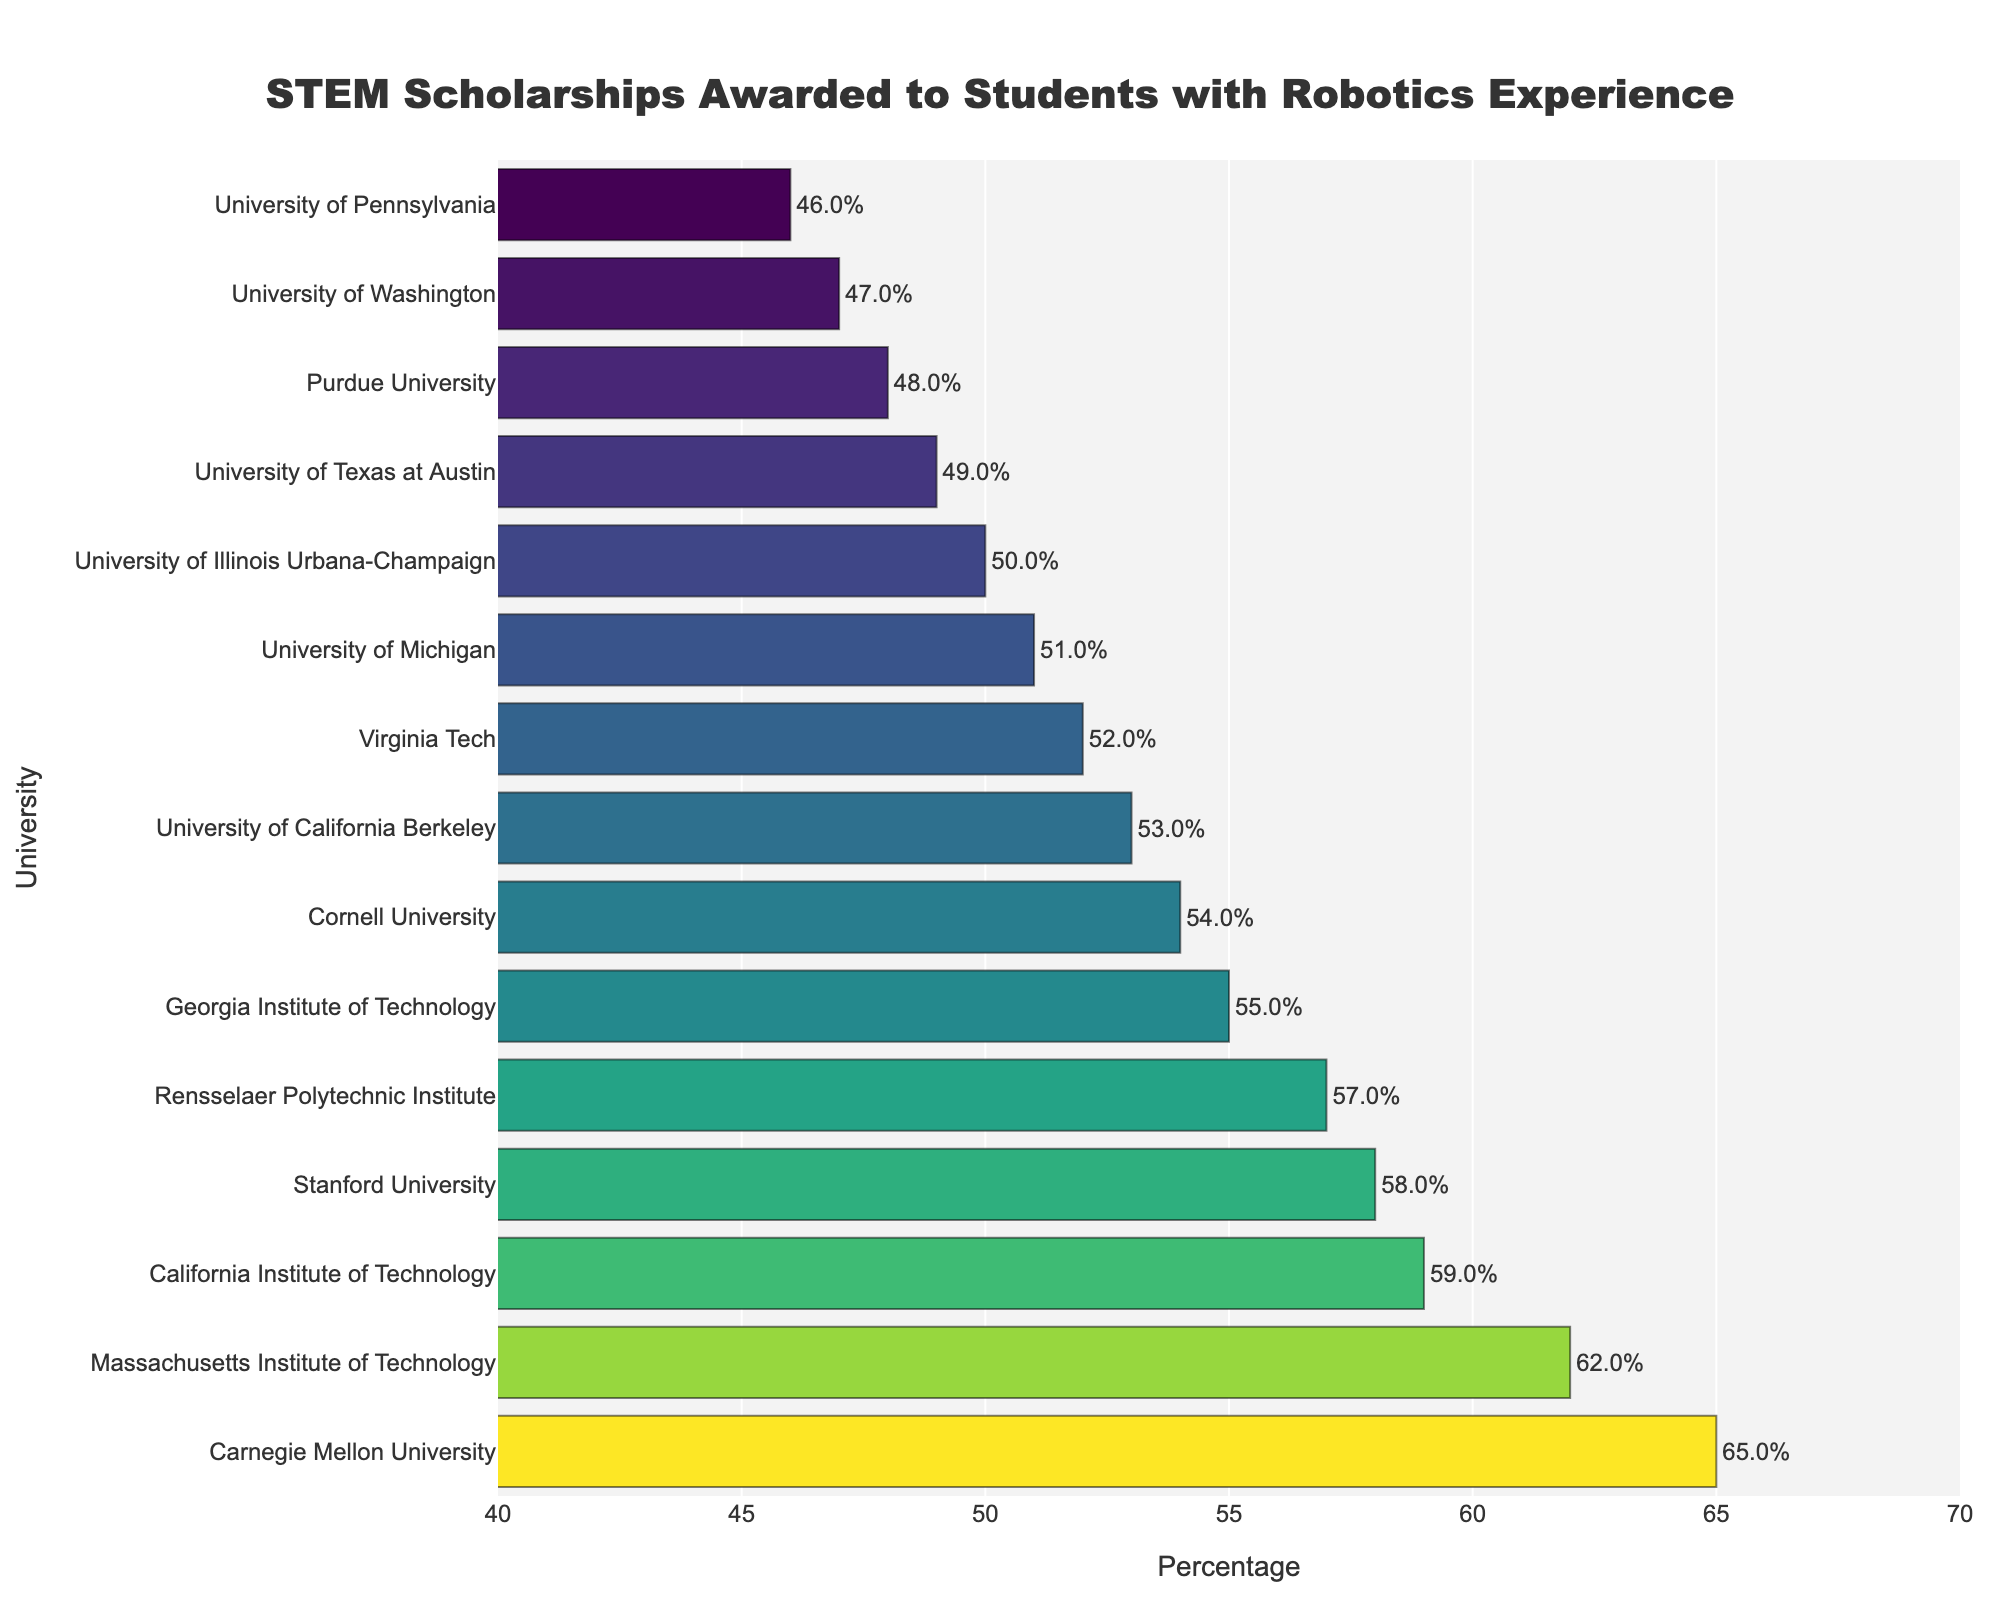What university has the highest percentage of STEM scholarships awarded to students with robotics experience? Look at the height of the bars in the bar chart and identify the bar that reaches the highest point on the percentage axis.
Answer: Carnegie Mellon University Which university has the lowest percentage of STEM scholarships awarded to students with robotics experience? Look at the height of the bars in the bar chart and identify the bar that reaches the lowest point on the percentage axis.
Answer: University of Pennsylvania What is the percentage difference between Massachusetts Institute of Technology and California Institute of Technology? Look at the percentage values on the bars representing Massachusetts Institute of Technology (62%) and California Institute of Technology (59%), and calculate the difference: 62 - 59 = 3.
Answer: 3% What is the average percentage of STEM scholarships awarded to students with robotics experience across all universities? Sum all the percentage values and divide by the number of universities: (62 + 58 + 65 + 59 + 55 + 51 + 48 + 53 + 50 + 54 + 47 + 49 + 57 + 52 + 46)/15 ≈ 54.13.
Answer: 54.13% How many universities have a percentage of STEM scholarships awarded to students with robotics experience greater than 50%? Count the number of bars that exceed the 50% mark.
Answer: 9 Which universities have a percentage of STEM scholarships awarded to students with robotics experience equal to or below 50%? Identify the bars that are at or below the 50% mark: Purdue University (48), University of Illinois Urbana-Champaign (50), University of Washington (47), University of Texas at Austin (49), University of Pennsylvania (46).
Answer: Purdue University, University of Illinois Urbana-Champaign, University of Washington, University of Texas at Austin, University of Pennsylvania What is the range of the percentages of STEM scholarships awarded? Subtract the lowest percentage value from the highest percentage value: 65 - 46 = 19.
Answer: 19% Which university has a percentage closest to the average? Calculate the average (54.13%) and find the university with a percentage closest to this value: Cornell University with 54%.
Answer: Cornell University 